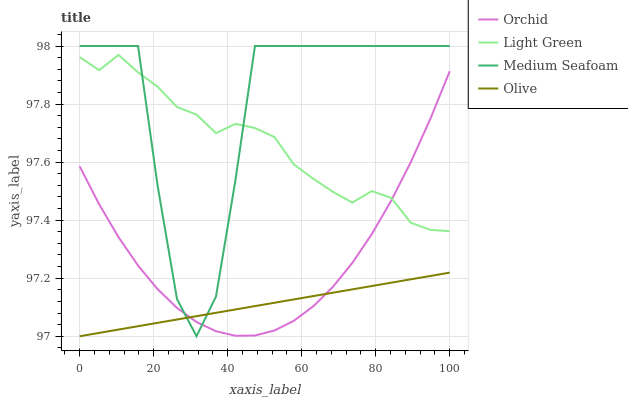Does Olive have the minimum area under the curve?
Answer yes or no. Yes. Does Medium Seafoam have the maximum area under the curve?
Answer yes or no. Yes. Does Light Green have the minimum area under the curve?
Answer yes or no. No. Does Light Green have the maximum area under the curve?
Answer yes or no. No. Is Olive the smoothest?
Answer yes or no. Yes. Is Medium Seafoam the roughest?
Answer yes or no. Yes. Is Light Green the smoothest?
Answer yes or no. No. Is Light Green the roughest?
Answer yes or no. No. Does Olive have the lowest value?
Answer yes or no. Yes. Does Medium Seafoam have the lowest value?
Answer yes or no. No. Does Medium Seafoam have the highest value?
Answer yes or no. Yes. Does Light Green have the highest value?
Answer yes or no. No. Is Olive less than Light Green?
Answer yes or no. Yes. Is Light Green greater than Olive?
Answer yes or no. Yes. Does Light Green intersect Orchid?
Answer yes or no. Yes. Is Light Green less than Orchid?
Answer yes or no. No. Is Light Green greater than Orchid?
Answer yes or no. No. Does Olive intersect Light Green?
Answer yes or no. No. 